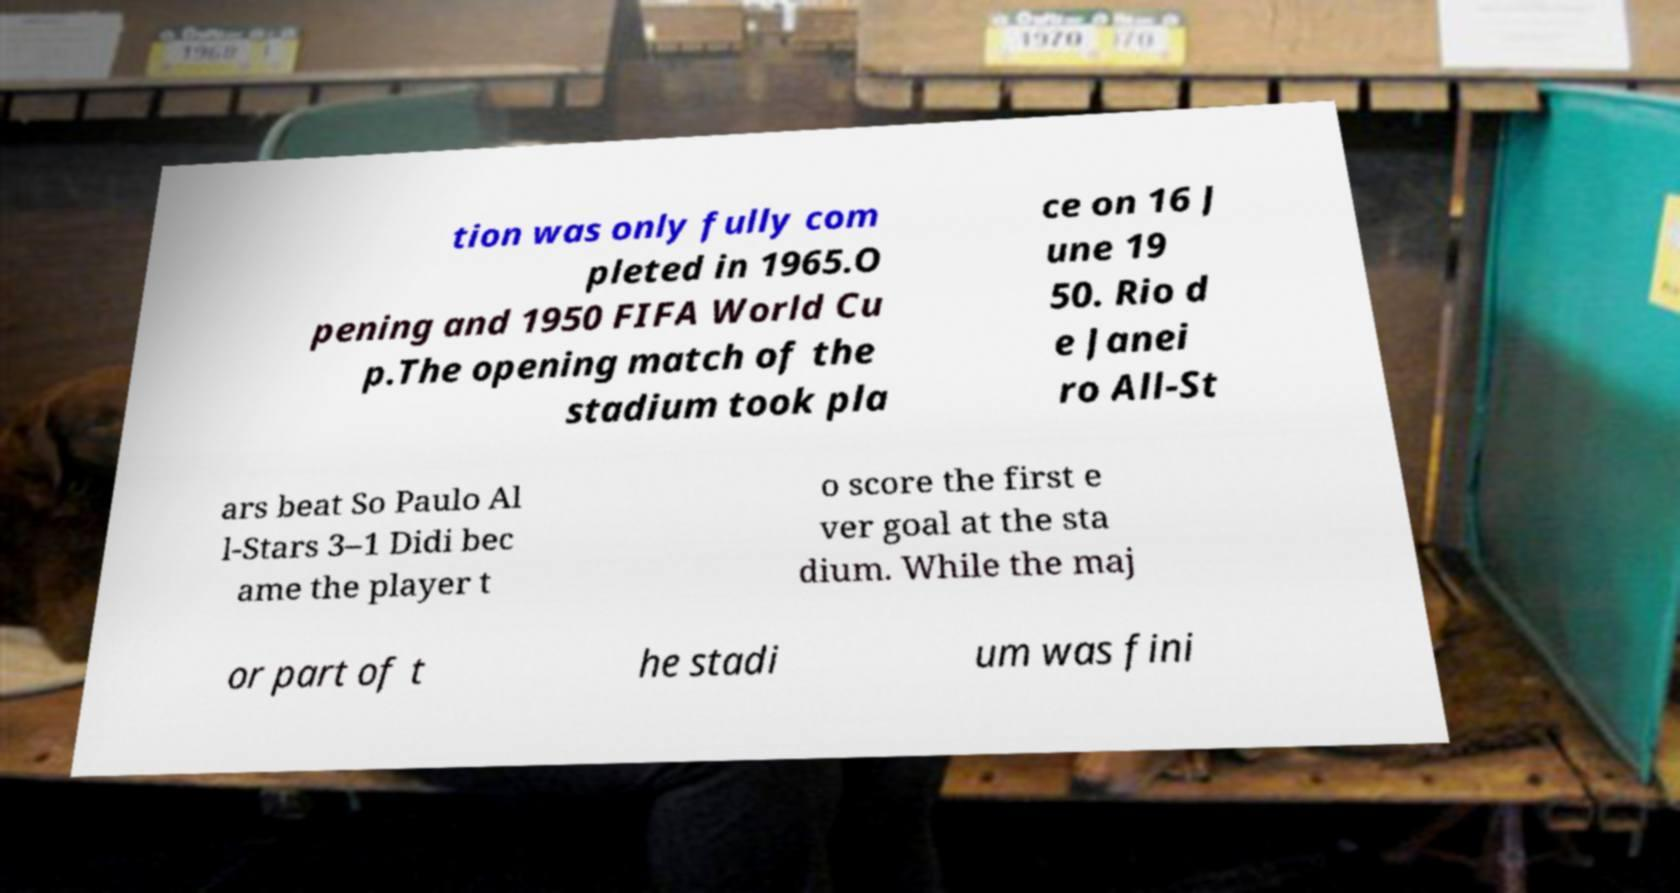What messages or text are displayed in this image? I need them in a readable, typed format. tion was only fully com pleted in 1965.O pening and 1950 FIFA World Cu p.The opening match of the stadium took pla ce on 16 J une 19 50. Rio d e Janei ro All-St ars beat So Paulo Al l-Stars 3–1 Didi bec ame the player t o score the first e ver goal at the sta dium. While the maj or part of t he stadi um was fini 